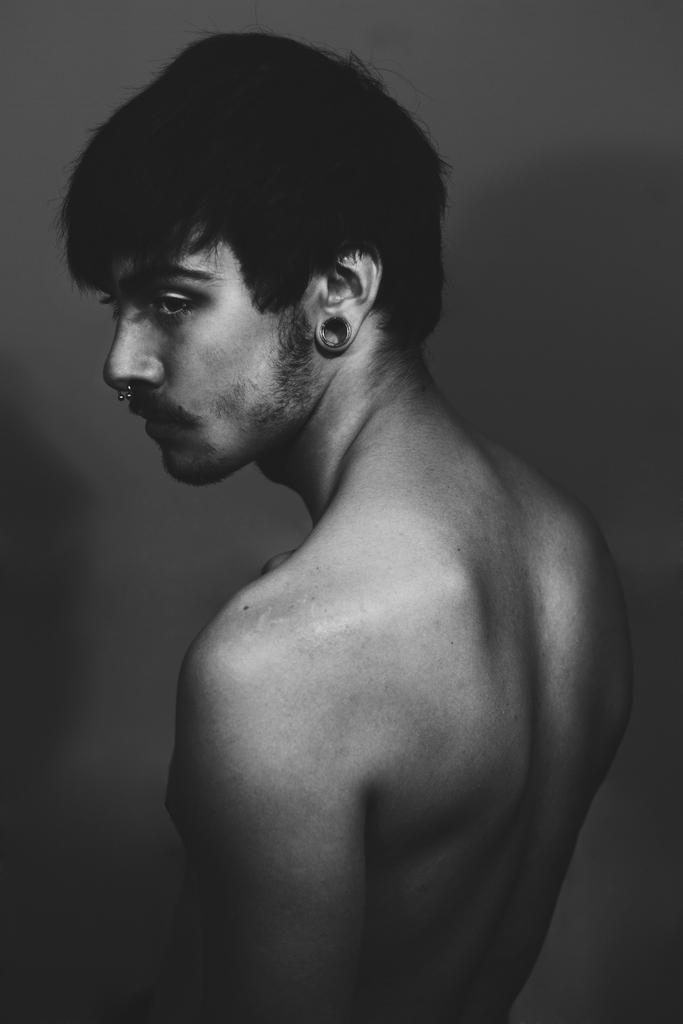What is the color scheme of the image? The image is black and white. Who is present in the image? There is a man in the image. What is the man wearing in the image? The man is not wearing a shirt in the image. What type of jewelry does the man have in the image? The man has earrings and a nose ring in the image. Can you see any nails or wings on the man in the image? No, there are no nails or wings visible on the man in the image. 